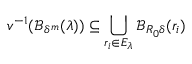<formula> <loc_0><loc_0><loc_500><loc_500>v ^ { - 1 } ( \mathcal { B } _ { \delta ^ { m } } ( \lambda ) ) \subseteq \bigcup _ { r _ { i } \in E _ { \lambda } } \mathcal { B } _ { R _ { 0 } \delta } ( r _ { i } )</formula> 